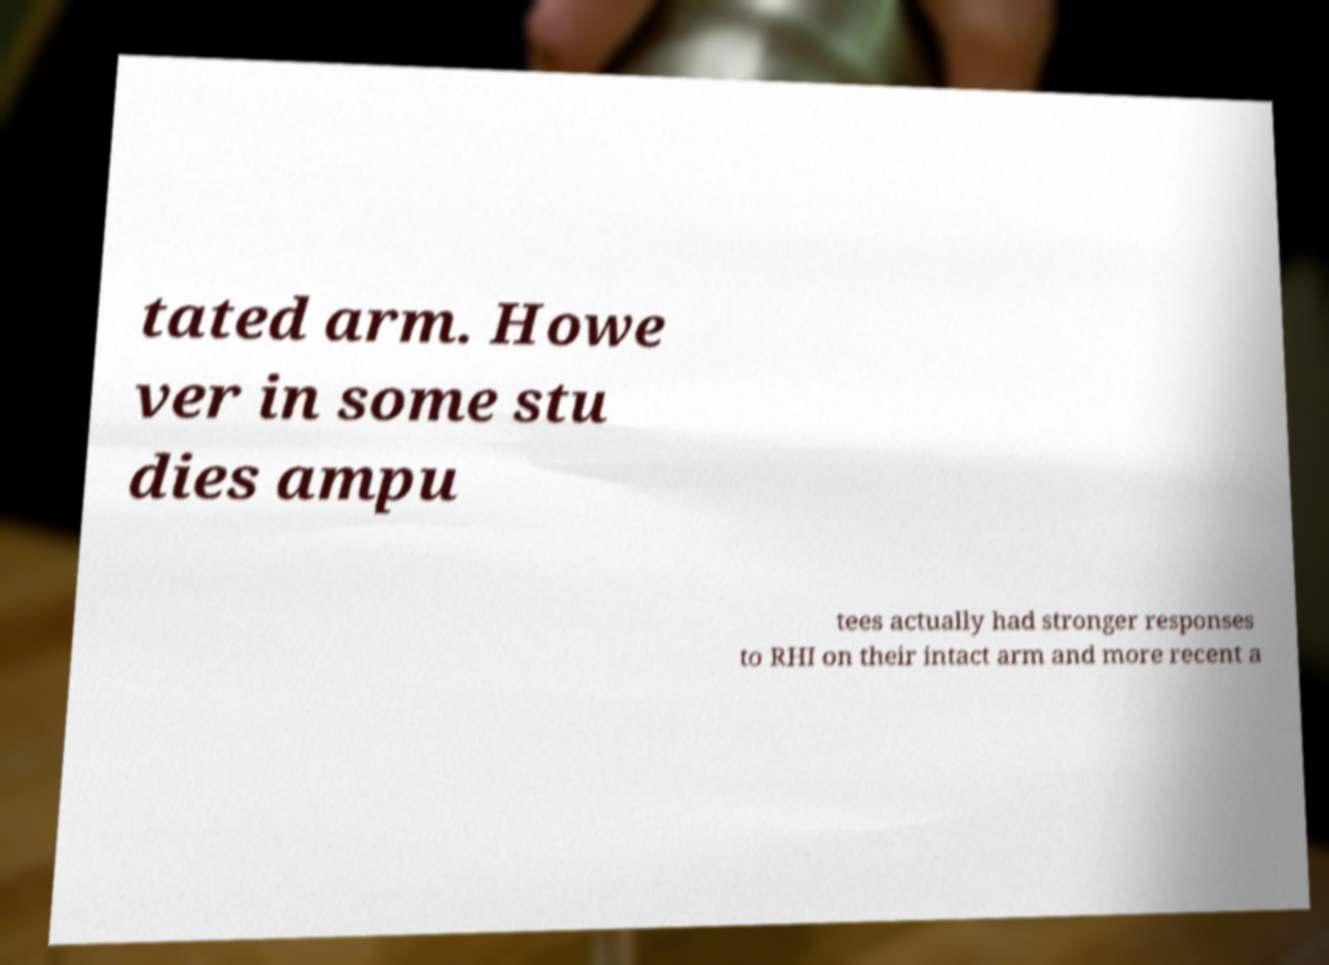Please identify and transcribe the text found in this image. tated arm. Howe ver in some stu dies ampu tees actually had stronger responses to RHI on their intact arm and more recent a 